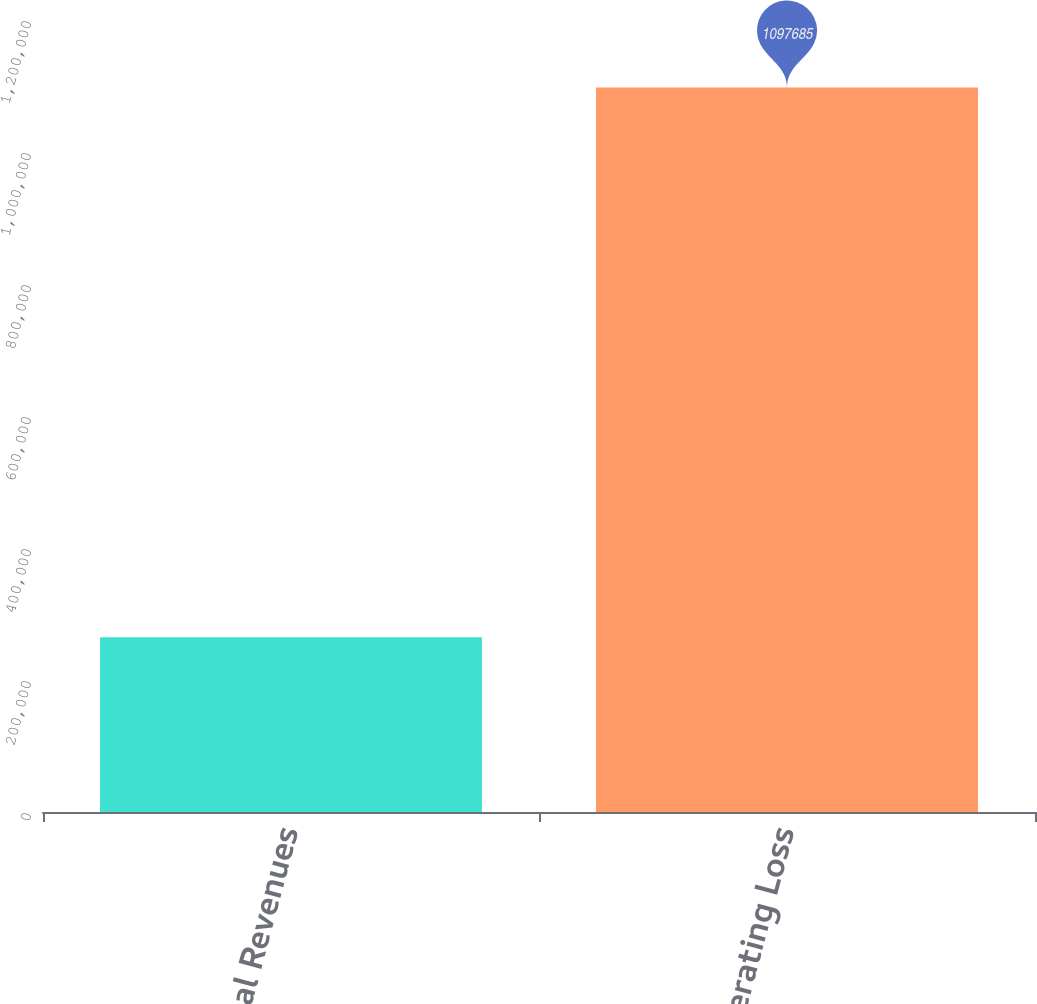Convert chart to OTSL. <chart><loc_0><loc_0><loc_500><loc_500><bar_chart><fcel>Total Revenues<fcel>Operating Loss<nl><fcel>264900<fcel>1.09768e+06<nl></chart> 